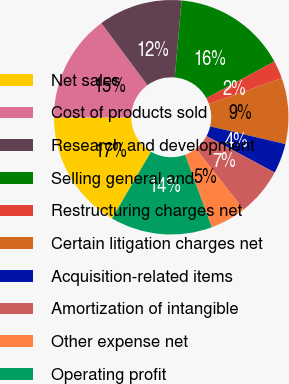<chart> <loc_0><loc_0><loc_500><loc_500><pie_chart><fcel>Net sales<fcel>Cost of products sold<fcel>Research and development<fcel>Selling general and<fcel>Restructuring charges net<fcel>Certain litigation charges net<fcel>Acquisition-related items<fcel>Amortization of intangible<fcel>Other expense net<fcel>Operating profit<nl><fcel>16.53%<fcel>14.88%<fcel>11.57%<fcel>15.7%<fcel>2.48%<fcel>9.09%<fcel>4.13%<fcel>6.61%<fcel>4.96%<fcel>14.05%<nl></chart> 